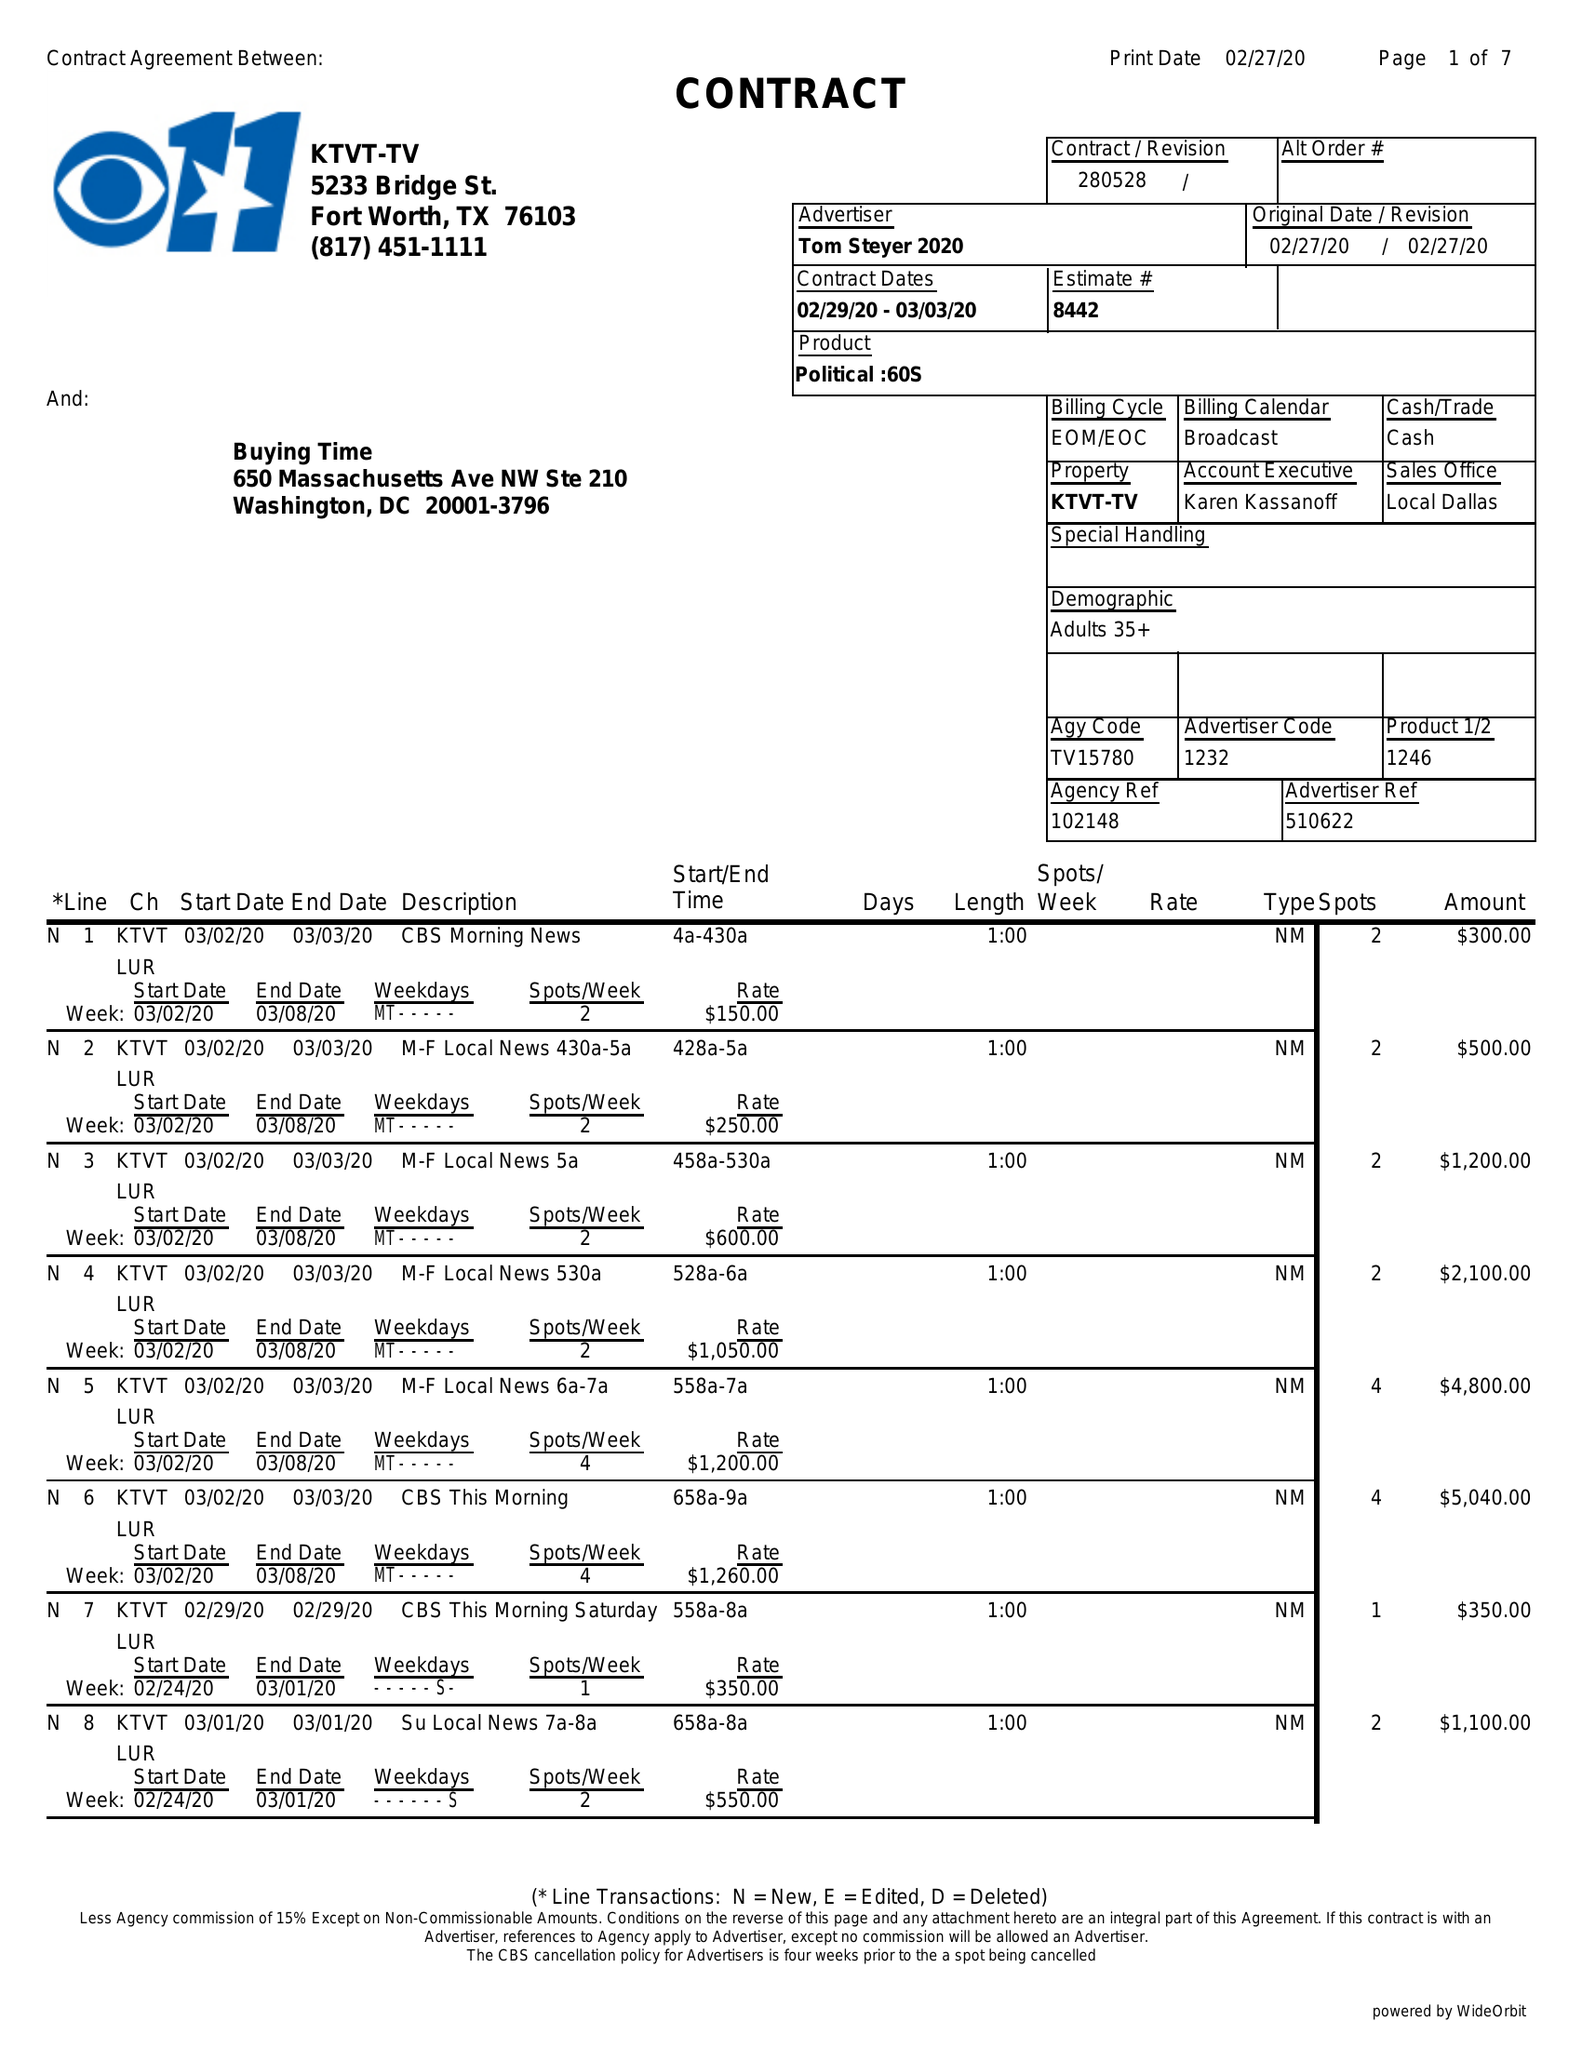What is the value for the flight_to?
Answer the question using a single word or phrase. 03/03/20 